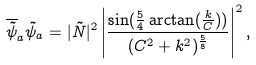Convert formula to latex. <formula><loc_0><loc_0><loc_500><loc_500>\overline { \tilde { \psi } } _ { a } \tilde { \psi } _ { a } = | \tilde { N } | ^ { 2 } \left | \frac { \sin ( \frac { 5 } { 4 } \arctan ( \frac { k } { C } ) ) } { ( C ^ { 2 } + k ^ { 2 } ) ^ { \frac { 5 } { 8 } } } \right | ^ { 2 } ,</formula> 